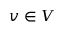<formula> <loc_0><loc_0><loc_500><loc_500>v \in V</formula> 